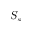Convert formula to latex. <formula><loc_0><loc_0><loc_500><loc_500>S _ { s }</formula> 